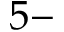<formula> <loc_0><loc_0><loc_500><loc_500>5 -</formula> 